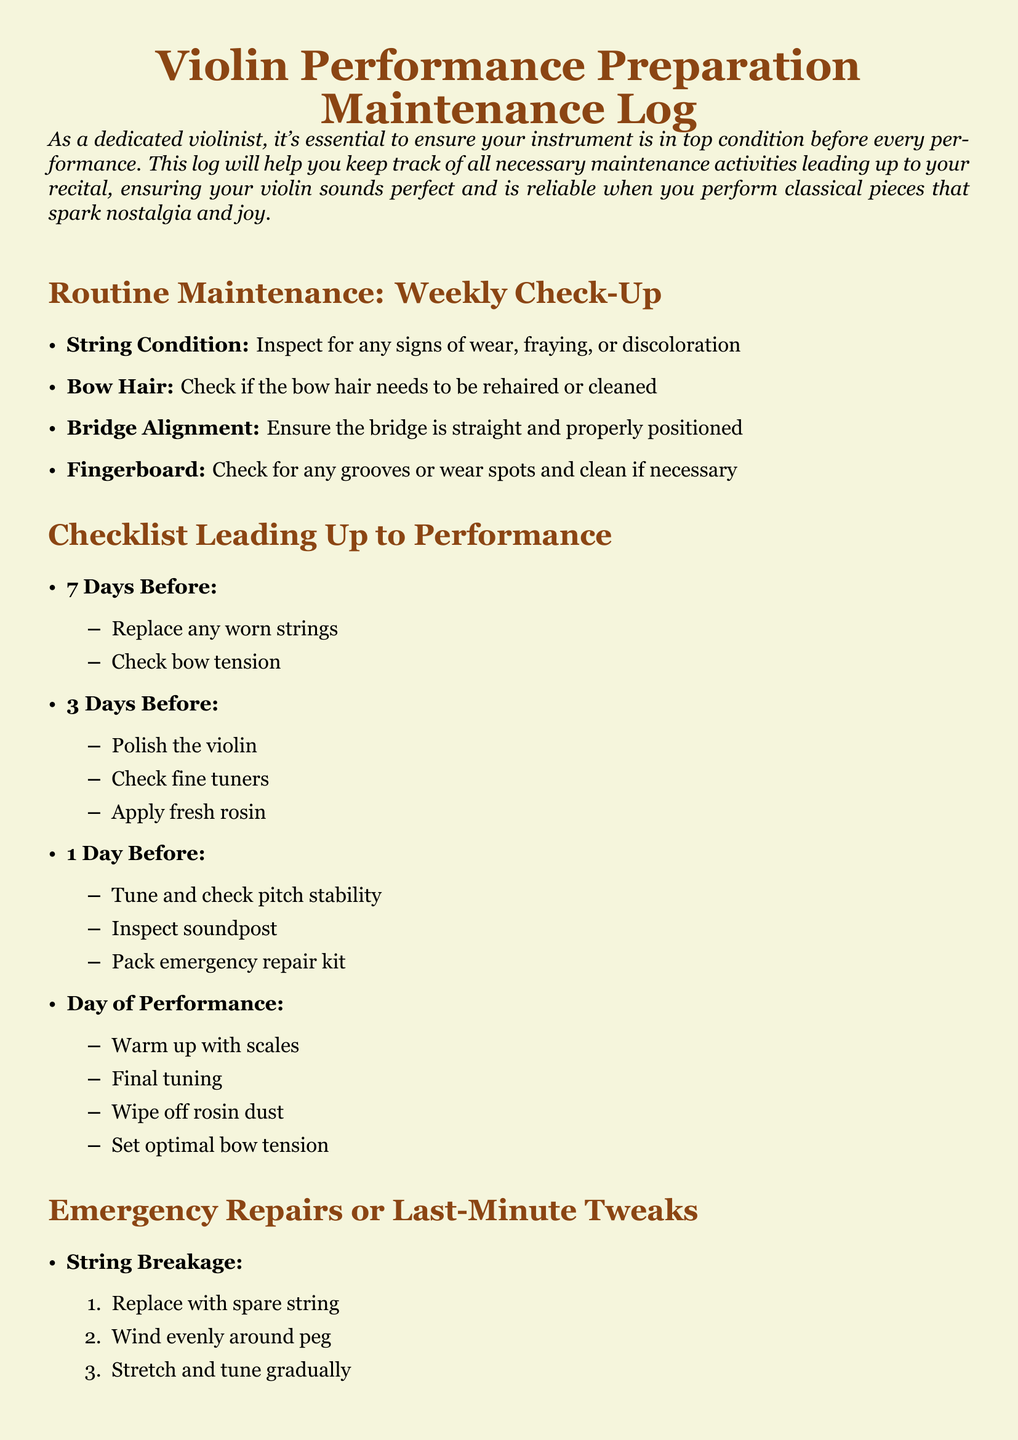What is the main title of the document? The title is prominently displayed at the top of the document, outlining its focus and purpose.
Answer: Violin Performance Preparation Maintenance Log How many days before a performance should you replace worn strings? The document specifies a timeline for activities leading up to the performance, indicating when specific tasks should be completed.
Answer: 7 Days Before What should be done on the day of the performance? The document provides a checklist of activities specifically scheduled for the performance day to ensure readiness.
Answer: Warm up with scales What is inspected 1 day before the performance? The document lists specific tasks to check on the eve of the performance, giving insight into last-minute preparations.
Answer: Inspect soundpost What is used to check bow hair condition? The maintenance log includes a regular check on the bow's condition, helping to ensure it performs well.
Answer: Check if the bow hair needs to be rehaired or cleaned What should be done if a string breaks? The document outlines emergency procedures and quick fixes for common issues, including string replacement steps.
Answer: Replace with spare string 